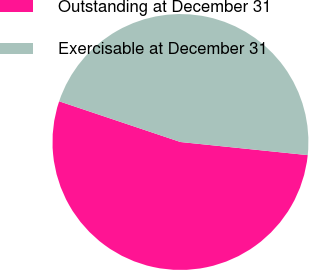<chart> <loc_0><loc_0><loc_500><loc_500><pie_chart><fcel>Outstanding at December 31<fcel>Exercisable at December 31<nl><fcel>53.52%<fcel>46.48%<nl></chart> 